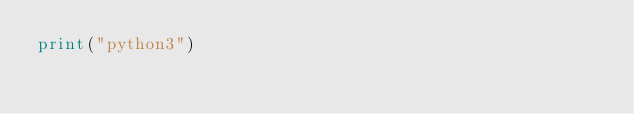<code> <loc_0><loc_0><loc_500><loc_500><_Python_>print("python3")</code> 